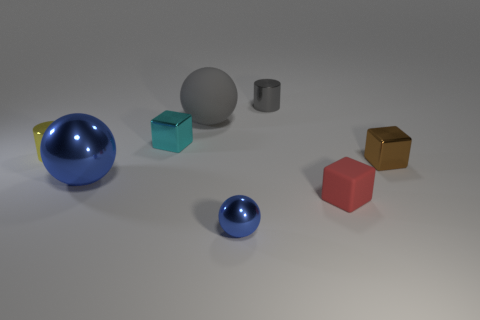Add 1 large rubber balls. How many objects exist? 9 Subtract all spheres. How many objects are left? 5 Subtract all small red matte things. Subtract all red rubber things. How many objects are left? 6 Add 7 tiny yellow metal cylinders. How many tiny yellow metal cylinders are left? 8 Add 6 tiny cyan rubber objects. How many tiny cyan rubber objects exist? 6 Subtract 0 blue cylinders. How many objects are left? 8 